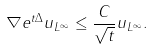Convert formula to latex. <formula><loc_0><loc_0><loc_500><loc_500>\| \nabla e ^ { t \Delta } u \| _ { L ^ { \infty } } \leq \frac { C } { \sqrt { t } } \| u \| _ { L ^ { \infty } } .</formula> 